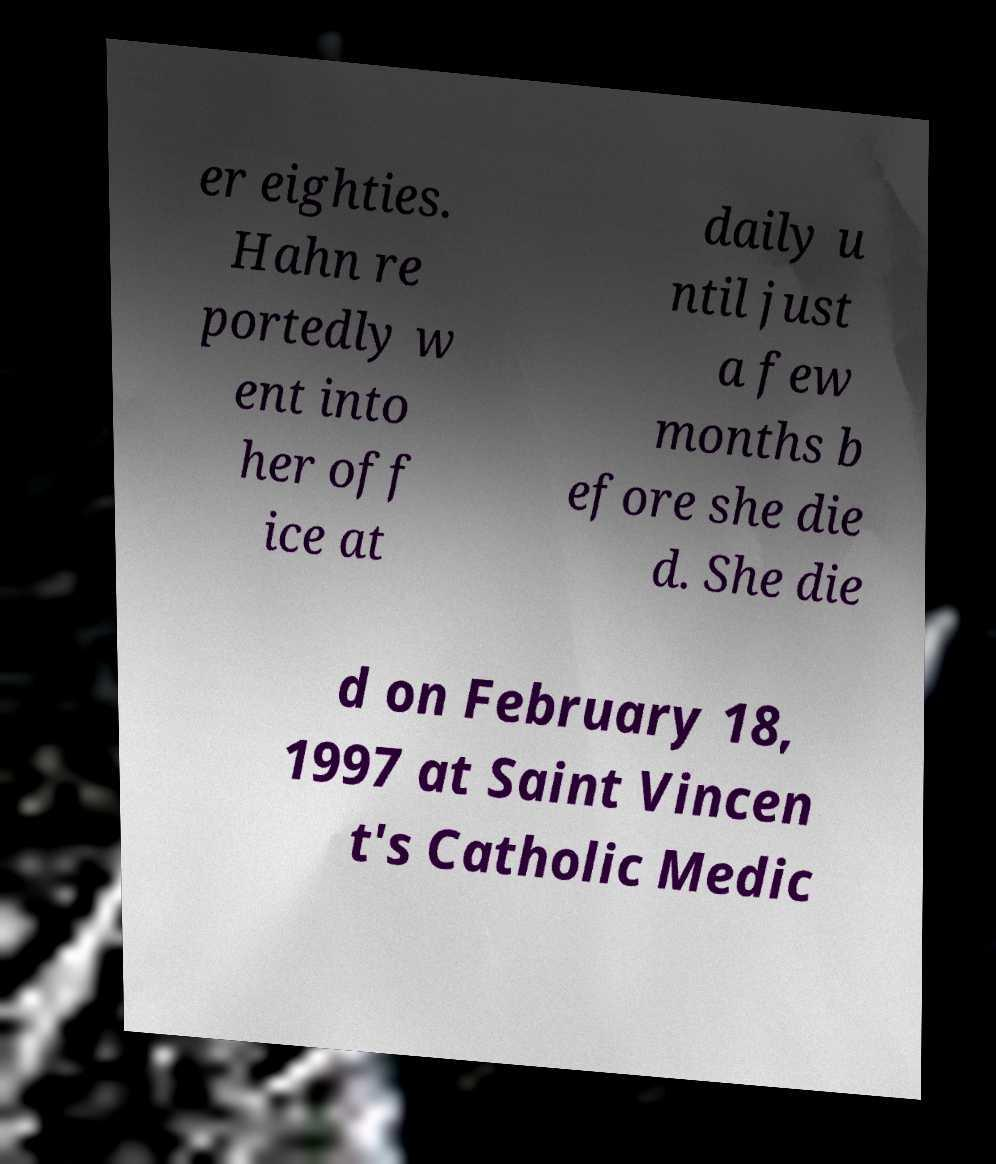For documentation purposes, I need the text within this image transcribed. Could you provide that? er eighties. Hahn re portedly w ent into her off ice at daily u ntil just a few months b efore she die d. She die d on February 18, 1997 at Saint Vincen t's Catholic Medic 